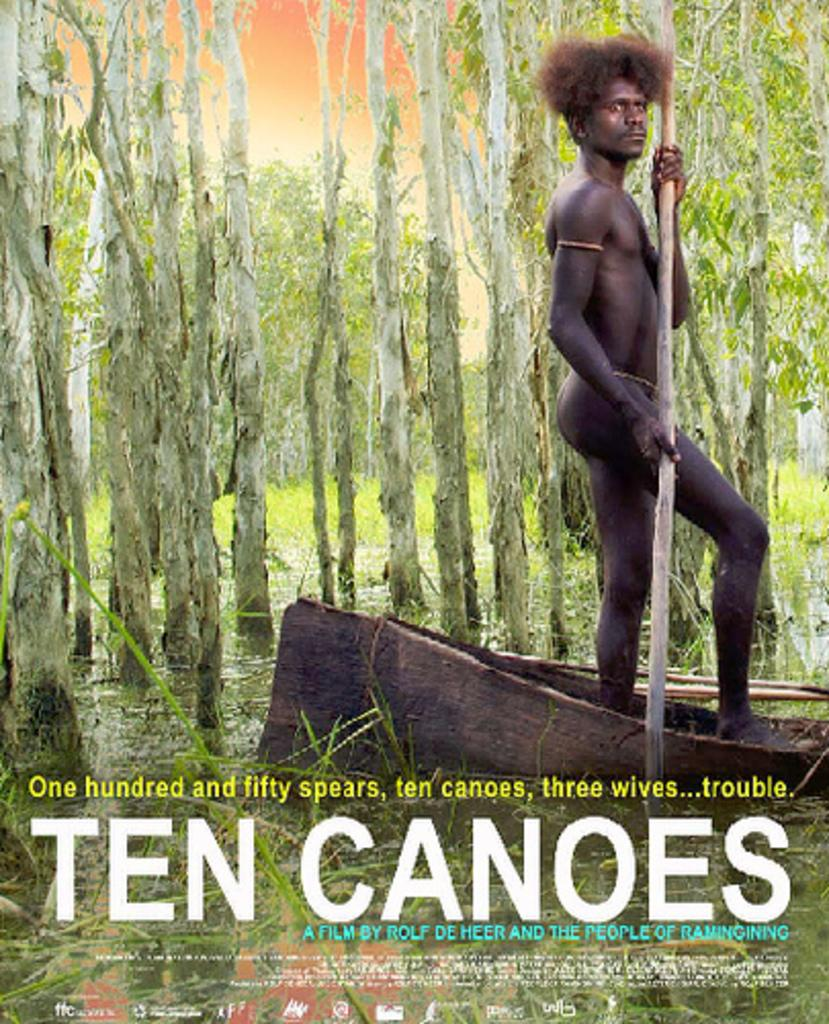What type of vegetation can be seen in the image? There are trees in the image. What is the man holding in the image? The man is holding a stick in the image. What is the man standing on in the image? The man is standing on a board in the image. What is visible at the bottom of the image? There is water visible at the bottom of the image. What can be seen in addition to the trees and the man? There is some text visible in the image. Can you see the man's toes in the image? There is no indication of the man's toes being visible in the image. What type of boat is present in the image? There is no boat present in the image. 